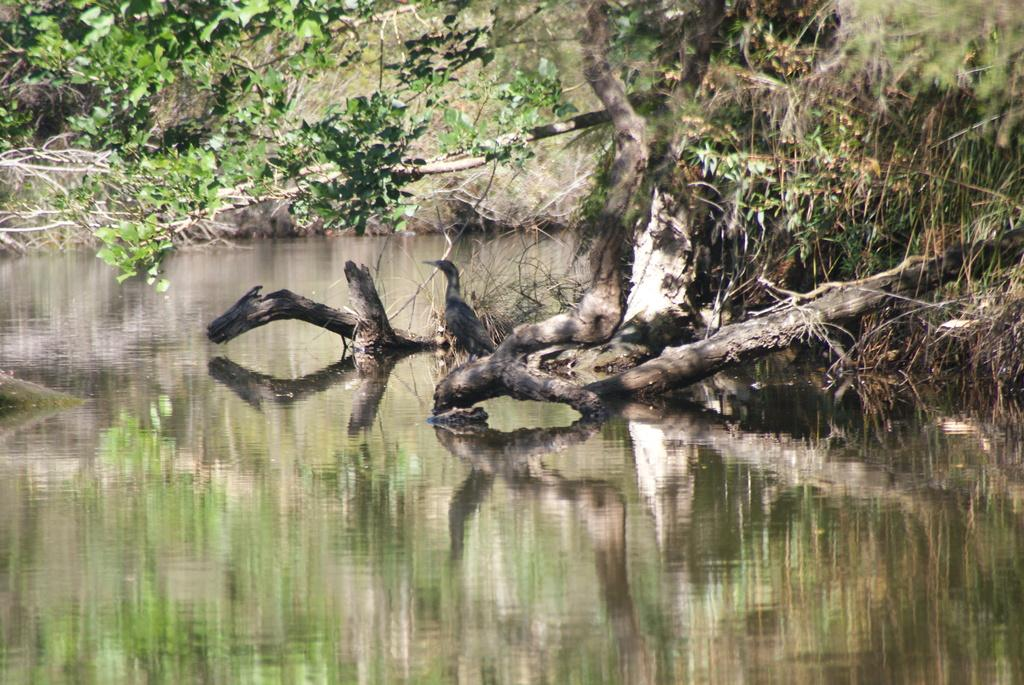What type of animal can be seen in the image? There is a bird in the image. Where is the bird located? The bird is on the branch of a tree. What can be seen in the background of the image? There is a water body and plants visible in the image. Can you describe the tree in the image? Yes, there is a tree in the image. What type of letter is the bird holding in its beak? There is no letter present in the image, and the bird is not holding anything in its beak. 